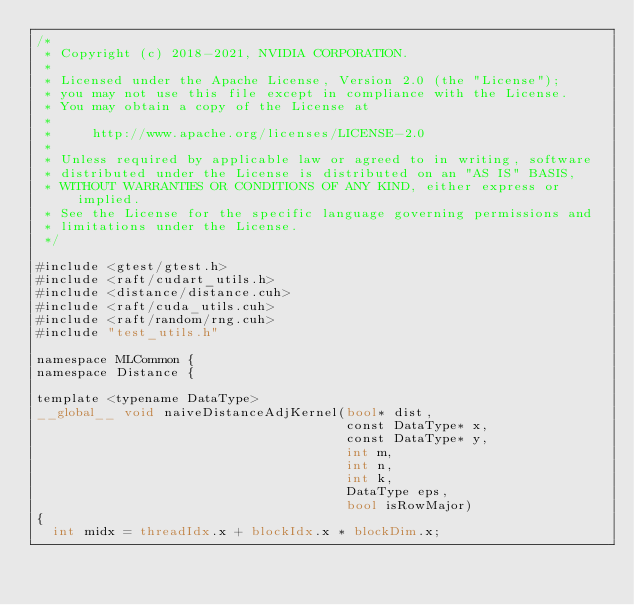<code> <loc_0><loc_0><loc_500><loc_500><_Cuda_>/*
 * Copyright (c) 2018-2021, NVIDIA CORPORATION.
 *
 * Licensed under the Apache License, Version 2.0 (the "License");
 * you may not use this file except in compliance with the License.
 * You may obtain a copy of the License at
 *
 *     http://www.apache.org/licenses/LICENSE-2.0
 *
 * Unless required by applicable law or agreed to in writing, software
 * distributed under the License is distributed on an "AS IS" BASIS,
 * WITHOUT WARRANTIES OR CONDITIONS OF ANY KIND, either express or implied.
 * See the License for the specific language governing permissions and
 * limitations under the License.
 */

#include <gtest/gtest.h>
#include <raft/cudart_utils.h>
#include <distance/distance.cuh>
#include <raft/cuda_utils.cuh>
#include <raft/random/rng.cuh>
#include "test_utils.h"

namespace MLCommon {
namespace Distance {

template <typename DataType>
__global__ void naiveDistanceAdjKernel(bool* dist,
                                       const DataType* x,
                                       const DataType* y,
                                       int m,
                                       int n,
                                       int k,
                                       DataType eps,
                                       bool isRowMajor)
{
  int midx = threadIdx.x + blockIdx.x * blockDim.x;</code> 